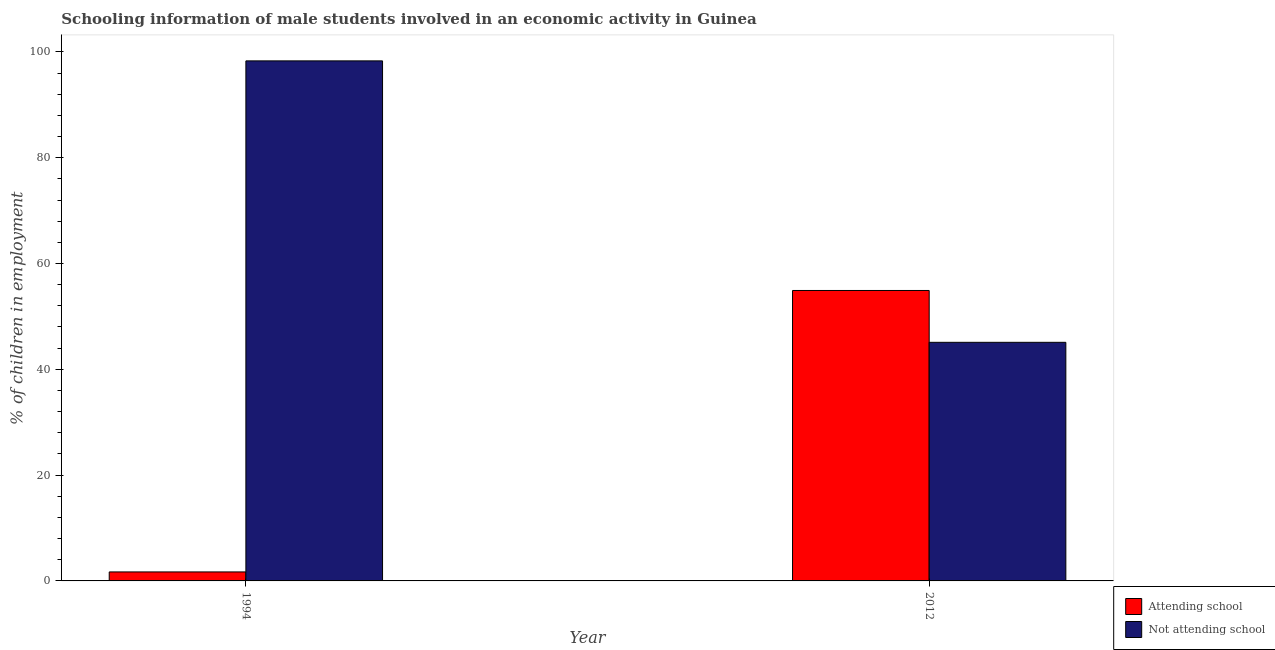Are the number of bars per tick equal to the number of legend labels?
Ensure brevity in your answer.  Yes. How many bars are there on the 2nd tick from the left?
Offer a very short reply. 2. What is the label of the 1st group of bars from the left?
Your answer should be very brief. 1994. In how many cases, is the number of bars for a given year not equal to the number of legend labels?
Keep it short and to the point. 0. What is the percentage of employed males who are attending school in 1994?
Give a very brief answer. 1.7. Across all years, what is the maximum percentage of employed males who are attending school?
Keep it short and to the point. 54.9. Across all years, what is the minimum percentage of employed males who are not attending school?
Offer a very short reply. 45.1. In which year was the percentage of employed males who are not attending school maximum?
Give a very brief answer. 1994. In which year was the percentage of employed males who are not attending school minimum?
Make the answer very short. 2012. What is the total percentage of employed males who are not attending school in the graph?
Keep it short and to the point. 143.4. What is the difference between the percentage of employed males who are not attending school in 1994 and that in 2012?
Make the answer very short. 53.2. What is the difference between the percentage of employed males who are not attending school in 1994 and the percentage of employed males who are attending school in 2012?
Give a very brief answer. 53.2. What is the average percentage of employed males who are attending school per year?
Your answer should be very brief. 28.3. In the year 2012, what is the difference between the percentage of employed males who are not attending school and percentage of employed males who are attending school?
Offer a very short reply. 0. In how many years, is the percentage of employed males who are attending school greater than 20 %?
Give a very brief answer. 1. What is the ratio of the percentage of employed males who are attending school in 1994 to that in 2012?
Ensure brevity in your answer.  0.03. Is the percentage of employed males who are not attending school in 1994 less than that in 2012?
Keep it short and to the point. No. In how many years, is the percentage of employed males who are not attending school greater than the average percentage of employed males who are not attending school taken over all years?
Your response must be concise. 1. What does the 1st bar from the left in 2012 represents?
Provide a succinct answer. Attending school. What does the 2nd bar from the right in 2012 represents?
Ensure brevity in your answer.  Attending school. Are all the bars in the graph horizontal?
Your answer should be compact. No. How many years are there in the graph?
Your answer should be very brief. 2. What is the difference between two consecutive major ticks on the Y-axis?
Your answer should be compact. 20. Does the graph contain any zero values?
Give a very brief answer. No. How many legend labels are there?
Offer a terse response. 2. How are the legend labels stacked?
Your answer should be very brief. Vertical. What is the title of the graph?
Make the answer very short. Schooling information of male students involved in an economic activity in Guinea. What is the label or title of the X-axis?
Provide a short and direct response. Year. What is the label or title of the Y-axis?
Ensure brevity in your answer.  % of children in employment. What is the % of children in employment in Not attending school in 1994?
Ensure brevity in your answer.  98.3. What is the % of children in employment in Attending school in 2012?
Give a very brief answer. 54.9. What is the % of children in employment in Not attending school in 2012?
Keep it short and to the point. 45.1. Across all years, what is the maximum % of children in employment of Attending school?
Give a very brief answer. 54.9. Across all years, what is the maximum % of children in employment in Not attending school?
Keep it short and to the point. 98.3. Across all years, what is the minimum % of children in employment in Attending school?
Offer a very short reply. 1.7. Across all years, what is the minimum % of children in employment of Not attending school?
Provide a short and direct response. 45.1. What is the total % of children in employment of Attending school in the graph?
Give a very brief answer. 56.6. What is the total % of children in employment in Not attending school in the graph?
Give a very brief answer. 143.4. What is the difference between the % of children in employment in Attending school in 1994 and that in 2012?
Your answer should be very brief. -53.2. What is the difference between the % of children in employment in Not attending school in 1994 and that in 2012?
Ensure brevity in your answer.  53.2. What is the difference between the % of children in employment in Attending school in 1994 and the % of children in employment in Not attending school in 2012?
Give a very brief answer. -43.4. What is the average % of children in employment of Attending school per year?
Keep it short and to the point. 28.3. What is the average % of children in employment in Not attending school per year?
Your answer should be compact. 71.7. In the year 1994, what is the difference between the % of children in employment of Attending school and % of children in employment of Not attending school?
Your answer should be very brief. -96.6. In the year 2012, what is the difference between the % of children in employment in Attending school and % of children in employment in Not attending school?
Provide a short and direct response. 9.8. What is the ratio of the % of children in employment in Attending school in 1994 to that in 2012?
Offer a very short reply. 0.03. What is the ratio of the % of children in employment in Not attending school in 1994 to that in 2012?
Make the answer very short. 2.18. What is the difference between the highest and the second highest % of children in employment in Attending school?
Ensure brevity in your answer.  53.2. What is the difference between the highest and the second highest % of children in employment in Not attending school?
Give a very brief answer. 53.2. What is the difference between the highest and the lowest % of children in employment of Attending school?
Your answer should be compact. 53.2. What is the difference between the highest and the lowest % of children in employment in Not attending school?
Offer a terse response. 53.2. 